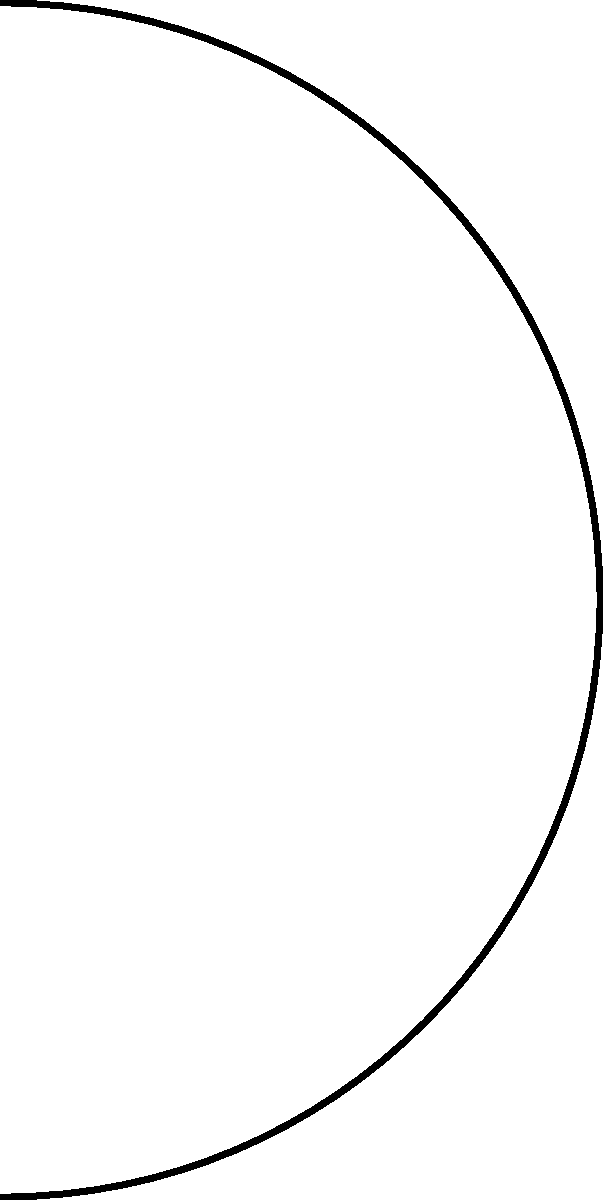In our favorite ramen shop, we notice they offer both ceramic and plastic bowls. Assuming the ramen broth is at a temperature $T_h = 95°C$ and the ambient air temperature is $T_a = 25°C$, which bowl material would keep the ramen hotter for a longer time? Consider that the thermal conductivity of ceramic is $k_c = 1.5 \text{ W/(m·K)}$ and plastic is $k_p = 0.25 \text{ W/(m·K)}$. The bowl thickness is the same for both materials. Let's approach this step-by-step:

1) The rate of heat transfer through a material is given by Fourier's law:

   $$ Q = -kA\frac{dT}{dx} $$

   Where $Q$ is the heat transfer rate, $k$ is the thermal conductivity, $A$ is the surface area, and $\frac{dT}{dx}$ is the temperature gradient.

2) For a simple comparison, we can assume the bowl thickness and surface area are the same for both materials. The temperature difference ($T_h - T_a$) is also the same.

3) Therefore, the heat transfer rate will be directly proportional to the thermal conductivity:

   $$ Q \propto k $$

4) Comparing the thermal conductivities:

   $$ \frac{Q_c}{Q_p} = \frac{k_c}{k_p} = \frac{1.5}{0.25} = 6 $$

5) This means that the ceramic bowl will transfer heat 6 times faster than the plastic bowl.

6) A faster heat transfer rate means the ramen in the ceramic bowl will cool down more quickly.

7) Therefore, the plastic bowl, with its lower thermal conductivity, will keep the ramen hotter for a longer time.
Answer: Plastic bowl 